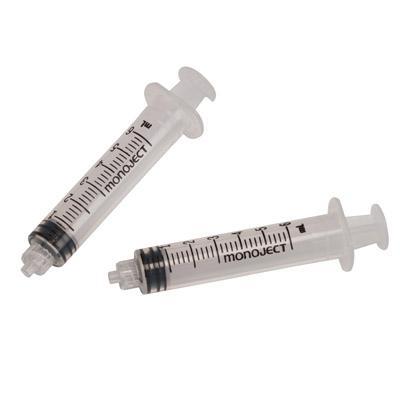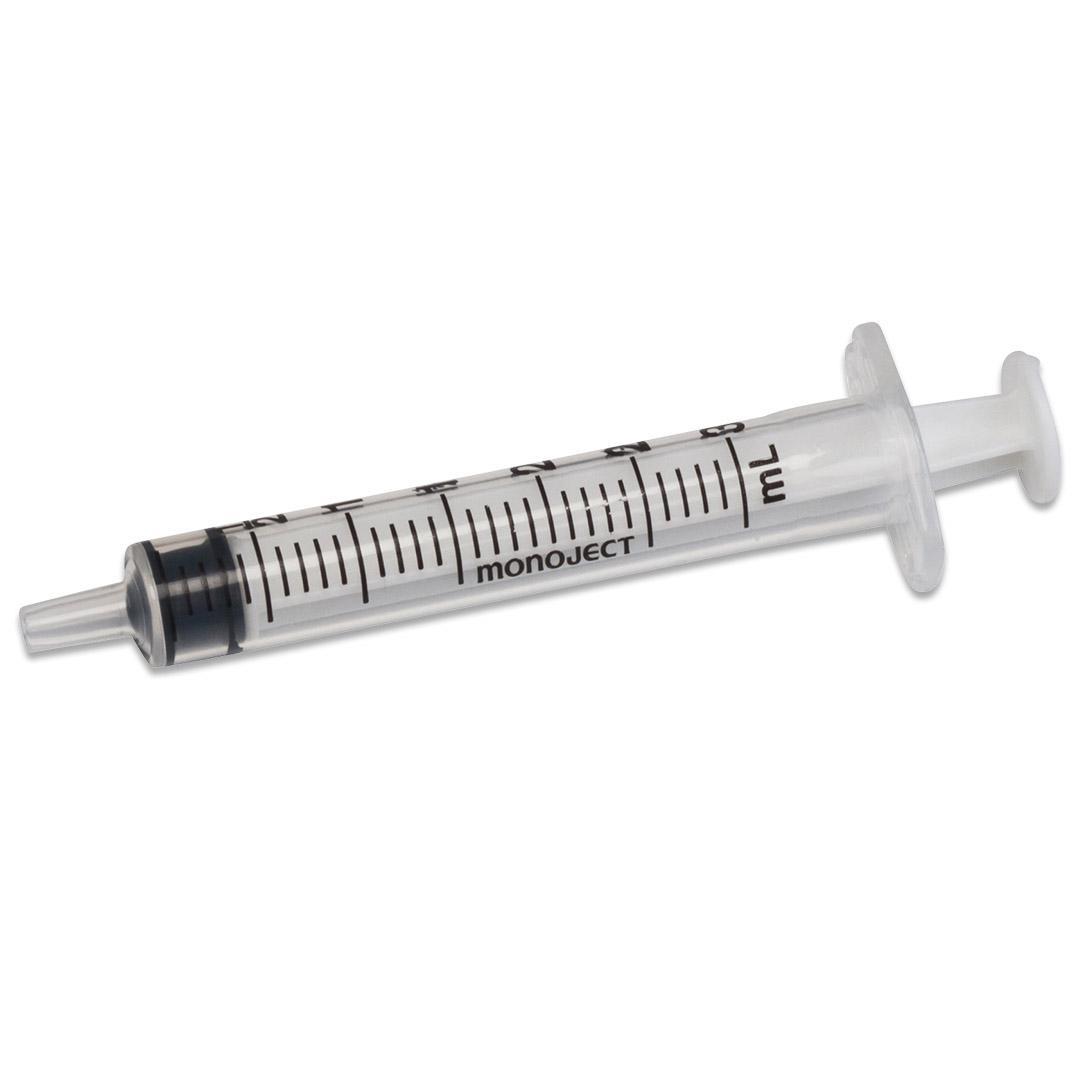The first image is the image on the left, the second image is the image on the right. For the images displayed, is the sentence "A blue cap is next to at least 1 syringe with a needle." factually correct? Answer yes or no. No. The first image is the image on the left, the second image is the image on the right. Considering the images on both sides, is "The combined images include a white wrapper and an upright blue lid behind a syringe with an exposed tip." valid? Answer yes or no. No. 